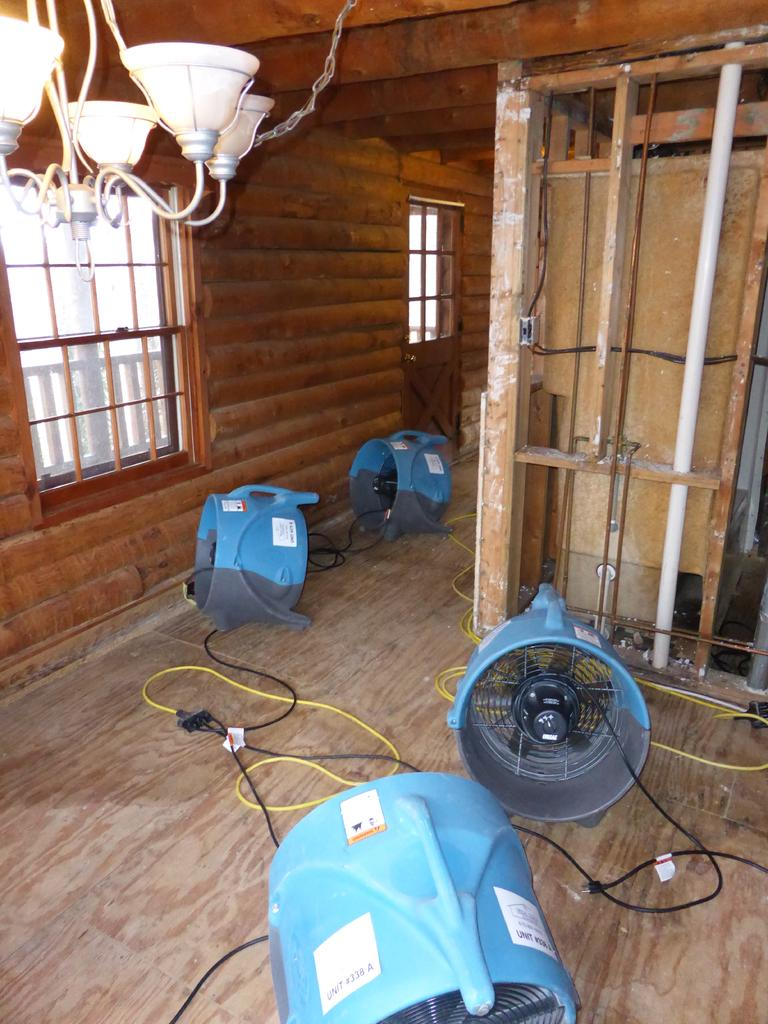What objects are on the ground in the image? There are fans on the ground in the image. What objects are on the ceiling in the image? There are lights on the ceiling in the image. What type of windows are present in the image? There are glass windows in the image. What material do the walls appear to be made of? The walls appear to be made of wood. How many boys are holding vegetables in the image? There are no boys or vegetables present in the image. 